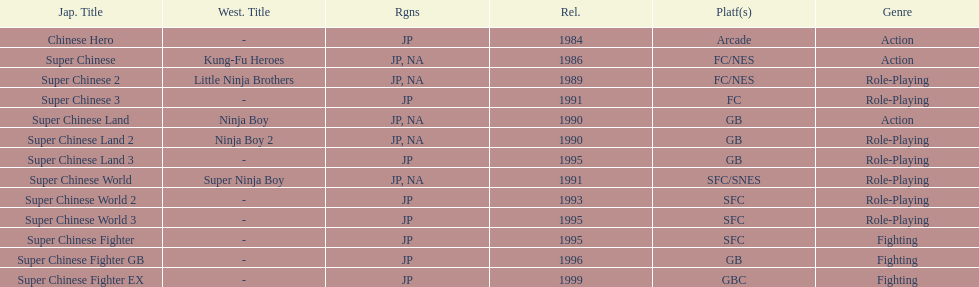Of the titles released in north america, which had the least releases? Super Chinese World. 